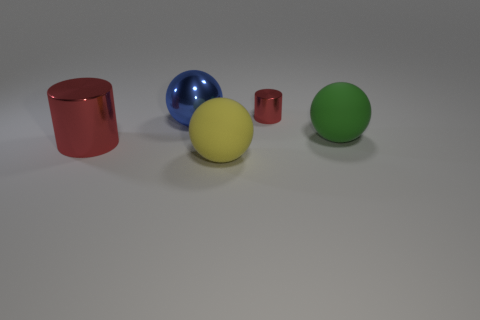Is there any other thing that has the same color as the large metallic ball?
Keep it short and to the point. No. Do the matte ball that is right of the tiny red metallic cylinder and the matte thing that is on the left side of the small metal thing have the same size?
Your response must be concise. Yes. The rubber object right of the red metallic cylinder that is behind the big shiny ball is what shape?
Provide a short and direct response. Sphere. Is the size of the blue metal ball the same as the rubber ball that is to the left of the tiny metal object?
Keep it short and to the point. Yes. There is a red thing that is in front of the red metal cylinder right of the large metallic thing that is in front of the green rubber sphere; how big is it?
Offer a very short reply. Large. What number of objects are either red cylinders on the right side of the large red cylinder or big objects?
Ensure brevity in your answer.  5. There is a shiny object that is in front of the big blue metal thing; what number of red objects are behind it?
Ensure brevity in your answer.  1. Are there more large red metal things in front of the big blue object than balls?
Make the answer very short. No. There is a sphere that is both on the left side of the large green ball and in front of the big blue shiny sphere; what is its size?
Your answer should be very brief. Large. There is a thing that is behind the big red metal thing and in front of the big blue shiny ball; what shape is it?
Your answer should be compact. Sphere. 